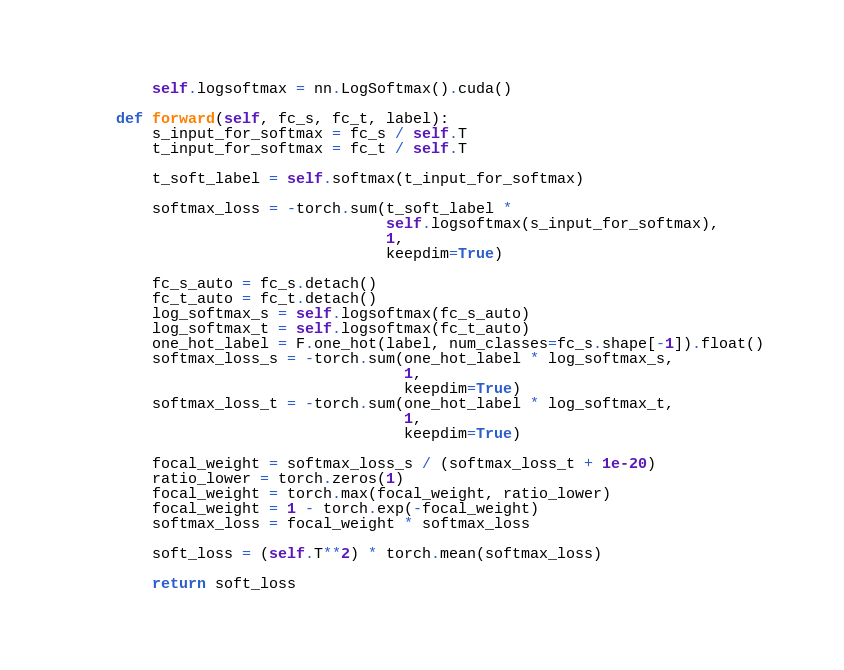<code> <loc_0><loc_0><loc_500><loc_500><_Python_>        self.logsoftmax = nn.LogSoftmax().cuda()

    def forward(self, fc_s, fc_t, label):
        s_input_for_softmax = fc_s / self.T
        t_input_for_softmax = fc_t / self.T

        t_soft_label = self.softmax(t_input_for_softmax)

        softmax_loss = -torch.sum(t_soft_label *
                                  self.logsoftmax(s_input_for_softmax),
                                  1,
                                  keepdim=True)

        fc_s_auto = fc_s.detach()
        fc_t_auto = fc_t.detach()
        log_softmax_s = self.logsoftmax(fc_s_auto)
        log_softmax_t = self.logsoftmax(fc_t_auto)
        one_hot_label = F.one_hot(label, num_classes=fc_s.shape[-1]).float()
        softmax_loss_s = -torch.sum(one_hot_label * log_softmax_s,
                                    1,
                                    keepdim=True)
        softmax_loss_t = -torch.sum(one_hot_label * log_softmax_t,
                                    1,
                                    keepdim=True)

        focal_weight = softmax_loss_s / (softmax_loss_t + 1e-20)
        ratio_lower = torch.zeros(1)
        focal_weight = torch.max(focal_weight, ratio_lower)
        focal_weight = 1 - torch.exp(-focal_weight)
        softmax_loss = focal_weight * softmax_loss

        soft_loss = (self.T**2) * torch.mean(softmax_loss)

        return soft_loss
</code> 